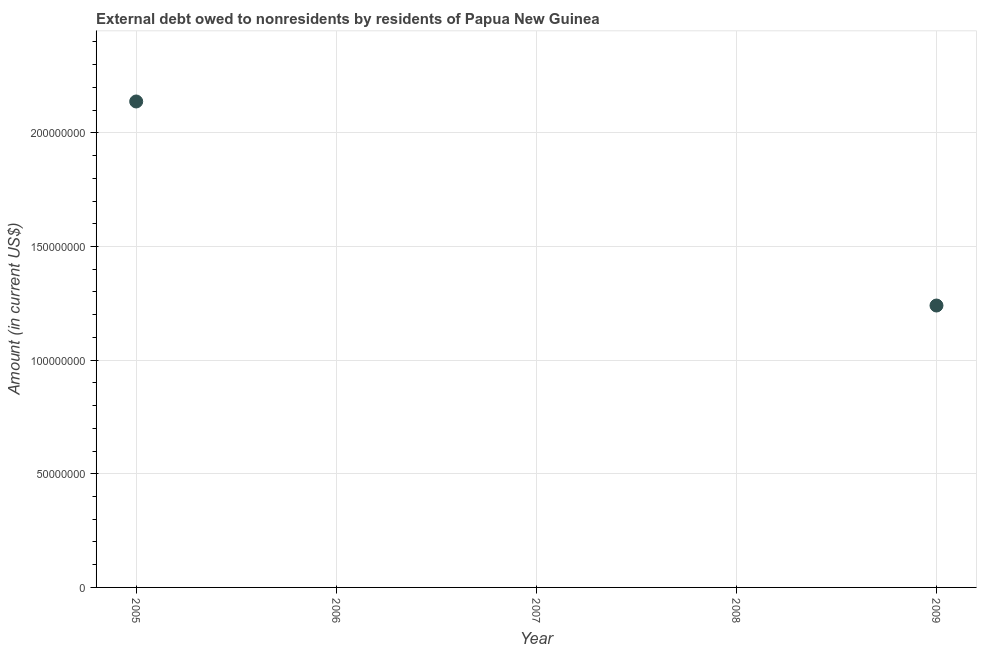What is the debt in 2005?
Provide a short and direct response. 2.14e+08. Across all years, what is the maximum debt?
Provide a succinct answer. 2.14e+08. Across all years, what is the minimum debt?
Offer a terse response. 0. What is the sum of the debt?
Keep it short and to the point. 3.38e+08. What is the difference between the debt in 2005 and 2009?
Give a very brief answer. 8.98e+07. What is the average debt per year?
Your response must be concise. 6.76e+07. What is the ratio of the debt in 2005 to that in 2009?
Provide a short and direct response. 1.72. What is the difference between the highest and the lowest debt?
Ensure brevity in your answer.  2.14e+08. Does the debt monotonically increase over the years?
Your answer should be very brief. No. How many years are there in the graph?
Your answer should be compact. 5. Does the graph contain grids?
Give a very brief answer. Yes. What is the title of the graph?
Ensure brevity in your answer.  External debt owed to nonresidents by residents of Papua New Guinea. What is the label or title of the Y-axis?
Give a very brief answer. Amount (in current US$). What is the Amount (in current US$) in 2005?
Offer a very short reply. 2.14e+08. What is the Amount (in current US$) in 2007?
Your answer should be very brief. 0. What is the Amount (in current US$) in 2008?
Your response must be concise. 0. What is the Amount (in current US$) in 2009?
Give a very brief answer. 1.24e+08. What is the difference between the Amount (in current US$) in 2005 and 2009?
Make the answer very short. 8.98e+07. What is the ratio of the Amount (in current US$) in 2005 to that in 2009?
Keep it short and to the point. 1.72. 